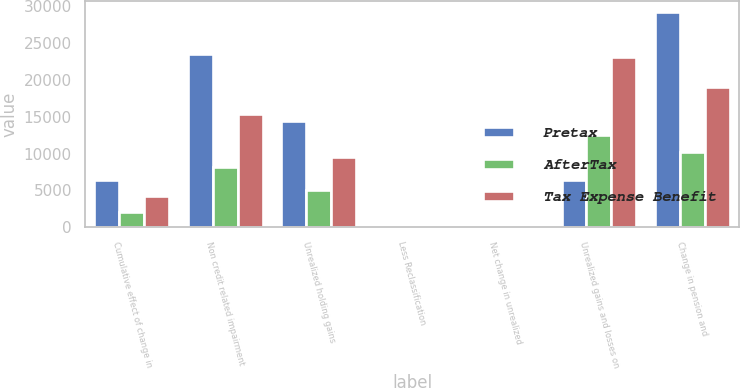Convert chart. <chart><loc_0><loc_0><loc_500><loc_500><stacked_bar_chart><ecel><fcel>Cumulative effect of change in<fcel>Non credit related impairment<fcel>Unrealized holding gains<fcel>Less Reclassification<fcel>Net change in unrealized<fcel>Unrealized gains and losses on<fcel>Change in pension and<nl><fcel>Pretax<fcel>6365<fcel>23569<fcel>14498<fcel>274<fcel>162<fcel>6365<fcel>29263<nl><fcel>AfterTax<fcel>2116<fcel>8249<fcel>5019<fcel>96<fcel>57<fcel>12468<fcel>10242<nl><fcel>Tax Expense Benefit<fcel>4249<fcel>15320<fcel>9479<fcel>178<fcel>105<fcel>23155<fcel>19021<nl></chart> 